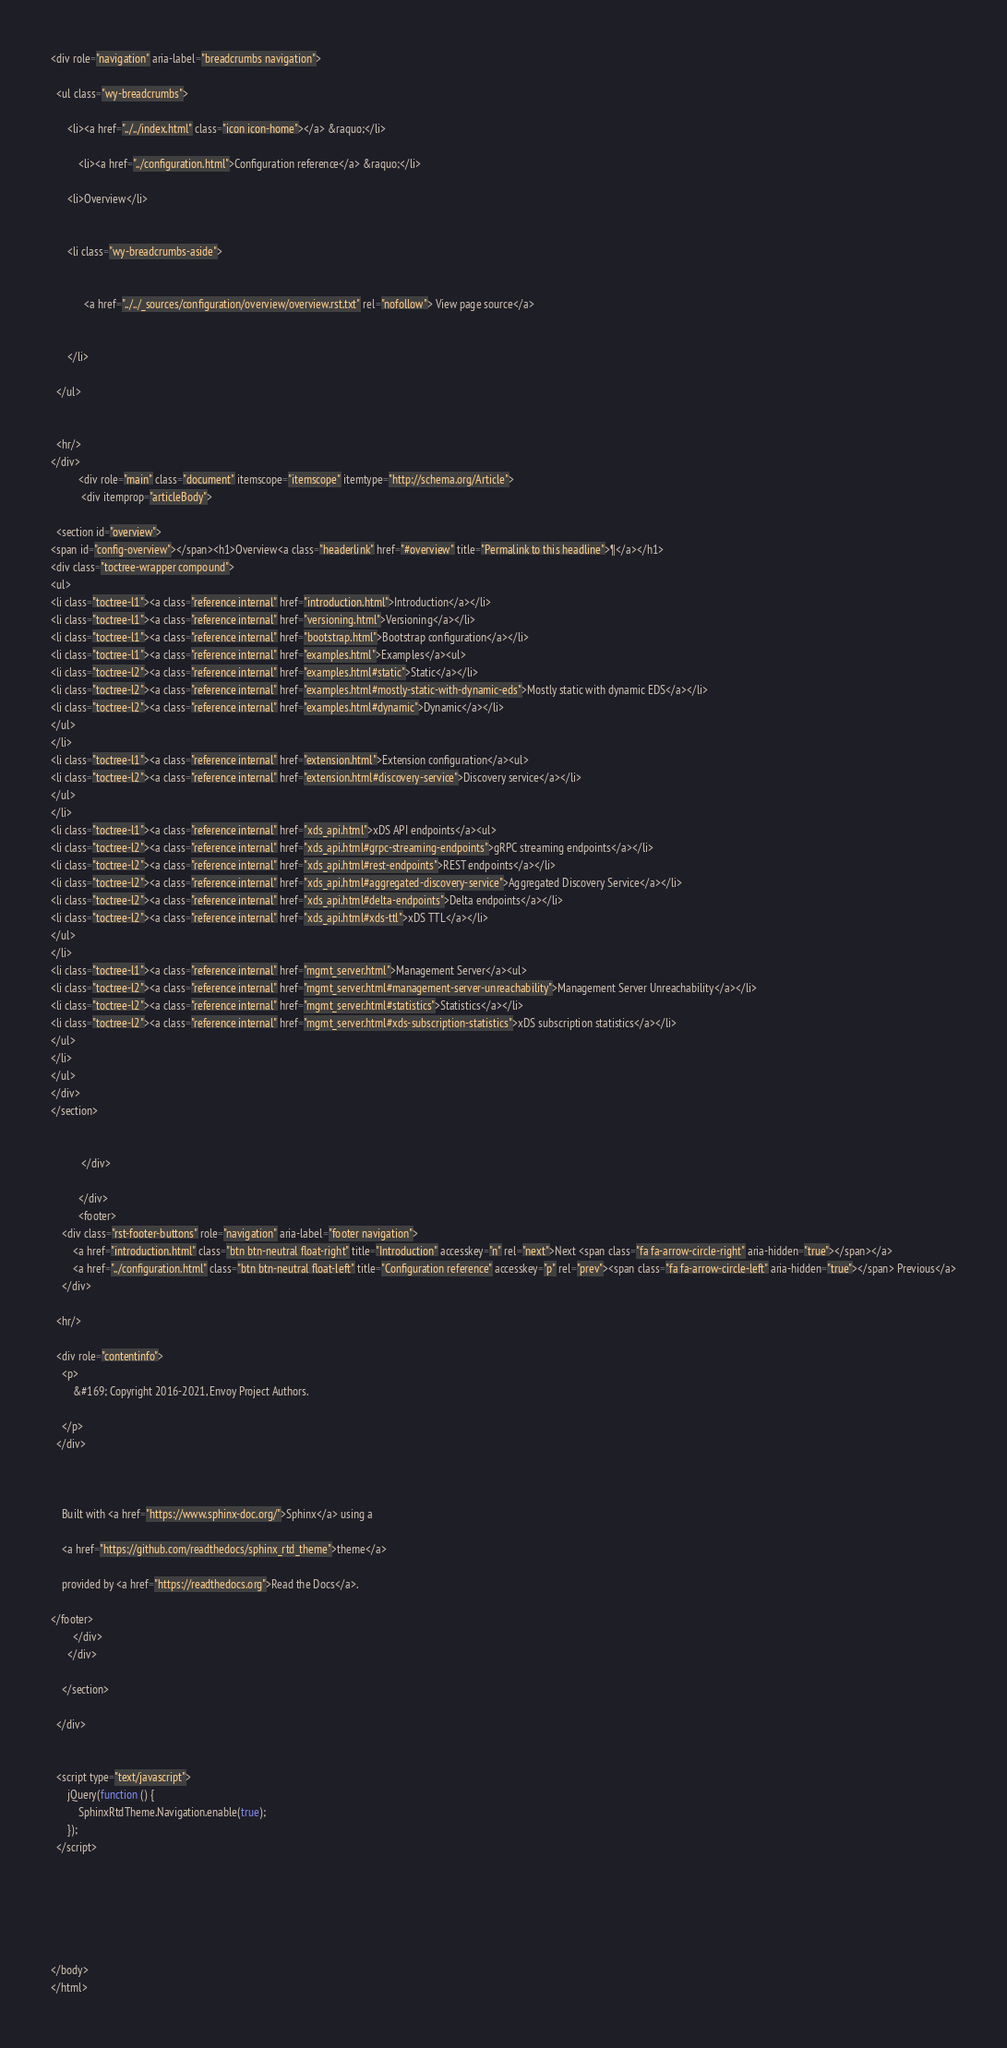<code> <loc_0><loc_0><loc_500><loc_500><_HTML_>
















<div role="navigation" aria-label="breadcrumbs navigation">

  <ul class="wy-breadcrumbs">
    
      <li><a href="../../index.html" class="icon icon-home"></a> &raquo;</li>
        
          <li><a href="../configuration.html">Configuration reference</a> &raquo;</li>
        
      <li>Overview</li>
    
    
      <li class="wy-breadcrumbs-aside">
        
          
            <a href="../../_sources/configuration/overview/overview.rst.txt" rel="nofollow"> View page source</a>
          
        
      </li>
    
  </ul>

  
  <hr/>
</div>
          <div role="main" class="document" itemscope="itemscope" itemtype="http://schema.org/Article">
           <div itemprop="articleBody">
            
  <section id="overview">
<span id="config-overview"></span><h1>Overview<a class="headerlink" href="#overview" title="Permalink to this headline">¶</a></h1>
<div class="toctree-wrapper compound">
<ul>
<li class="toctree-l1"><a class="reference internal" href="introduction.html">Introduction</a></li>
<li class="toctree-l1"><a class="reference internal" href="versioning.html">Versioning</a></li>
<li class="toctree-l1"><a class="reference internal" href="bootstrap.html">Bootstrap configuration</a></li>
<li class="toctree-l1"><a class="reference internal" href="examples.html">Examples</a><ul>
<li class="toctree-l2"><a class="reference internal" href="examples.html#static">Static</a></li>
<li class="toctree-l2"><a class="reference internal" href="examples.html#mostly-static-with-dynamic-eds">Mostly static with dynamic EDS</a></li>
<li class="toctree-l2"><a class="reference internal" href="examples.html#dynamic">Dynamic</a></li>
</ul>
</li>
<li class="toctree-l1"><a class="reference internal" href="extension.html">Extension configuration</a><ul>
<li class="toctree-l2"><a class="reference internal" href="extension.html#discovery-service">Discovery service</a></li>
</ul>
</li>
<li class="toctree-l1"><a class="reference internal" href="xds_api.html">xDS API endpoints</a><ul>
<li class="toctree-l2"><a class="reference internal" href="xds_api.html#grpc-streaming-endpoints">gRPC streaming endpoints</a></li>
<li class="toctree-l2"><a class="reference internal" href="xds_api.html#rest-endpoints">REST endpoints</a></li>
<li class="toctree-l2"><a class="reference internal" href="xds_api.html#aggregated-discovery-service">Aggregated Discovery Service</a></li>
<li class="toctree-l2"><a class="reference internal" href="xds_api.html#delta-endpoints">Delta endpoints</a></li>
<li class="toctree-l2"><a class="reference internal" href="xds_api.html#xds-ttl">xDS TTL</a></li>
</ul>
</li>
<li class="toctree-l1"><a class="reference internal" href="mgmt_server.html">Management Server</a><ul>
<li class="toctree-l2"><a class="reference internal" href="mgmt_server.html#management-server-unreachability">Management Server Unreachability</a></li>
<li class="toctree-l2"><a class="reference internal" href="mgmt_server.html#statistics">Statistics</a></li>
<li class="toctree-l2"><a class="reference internal" href="mgmt_server.html#xds-subscription-statistics">xDS subscription statistics</a></li>
</ul>
</li>
</ul>
</div>
</section>


           </div>
           
          </div>
          <footer>
    <div class="rst-footer-buttons" role="navigation" aria-label="footer navigation">
        <a href="introduction.html" class="btn btn-neutral float-right" title="Introduction" accesskey="n" rel="next">Next <span class="fa fa-arrow-circle-right" aria-hidden="true"></span></a>
        <a href="../configuration.html" class="btn btn-neutral float-left" title="Configuration reference" accesskey="p" rel="prev"><span class="fa fa-arrow-circle-left" aria-hidden="true"></span> Previous</a>
    </div>

  <hr/>

  <div role="contentinfo">
    <p>
        &#169; Copyright 2016-2021, Envoy Project Authors.

    </p>
  </div>
    
    
    
    Built with <a href="https://www.sphinx-doc.org/">Sphinx</a> using a
    
    <a href="https://github.com/readthedocs/sphinx_rtd_theme">theme</a>
    
    provided by <a href="https://readthedocs.org">Read the Docs</a>. 

</footer>
        </div>
      </div>

    </section>

  </div>
  

  <script type="text/javascript">
      jQuery(function () {
          SphinxRtdTheme.Navigation.enable(true);
      });
  </script>

  
  
    
   

</body>
</html></code> 